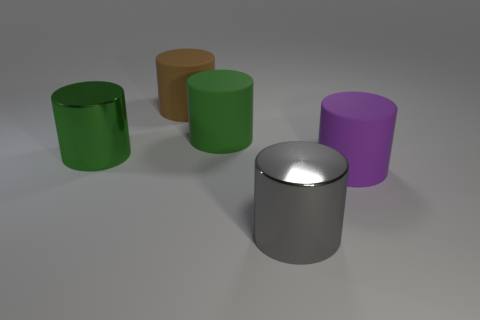Subtract all purple cylinders. How many cylinders are left? 4 Subtract 3 cylinders. How many cylinders are left? 2 Subtract all brown rubber cylinders. How many cylinders are left? 4 Subtract all cyan cylinders. Subtract all purple blocks. How many cylinders are left? 5 Add 3 large matte things. How many objects exist? 8 Add 4 big matte cylinders. How many big matte cylinders exist? 7 Subtract 0 red blocks. How many objects are left? 5 Subtract all big green cylinders. Subtract all large purple objects. How many objects are left? 2 Add 4 large gray metal objects. How many large gray metal objects are left? 5 